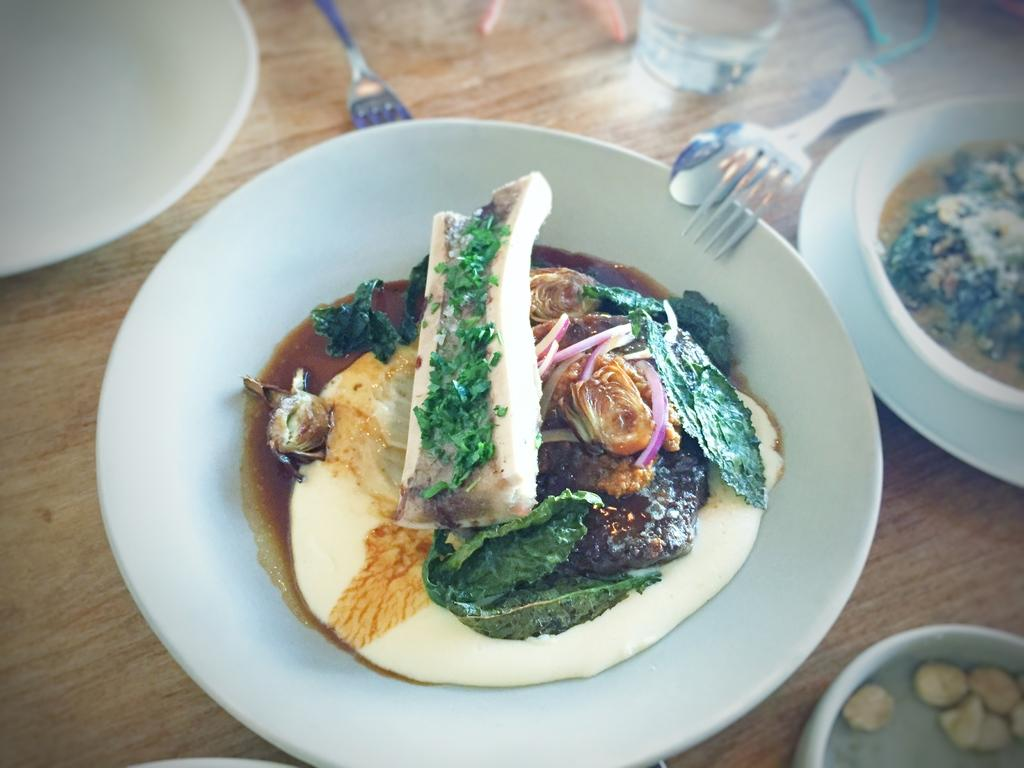What piece of furniture is present in the image? There is a table in the image. What type of tableware can be seen on the table? There are plates, bowls, and spoons on the table. What is the purpose of the glass on the table? The glass is likely for holding a beverage. What other objects are present on the table? There are other objects on the table, but their specific nature is not mentioned in the facts. What types of dishes are on the plates? The plates contain a variety of dishes, but the specific dishes are not mentioned in the facts. What is the title of the book that the sisters are reading in the image? There is no mention of a book or sisters in the image, so we cannot answer this question. 